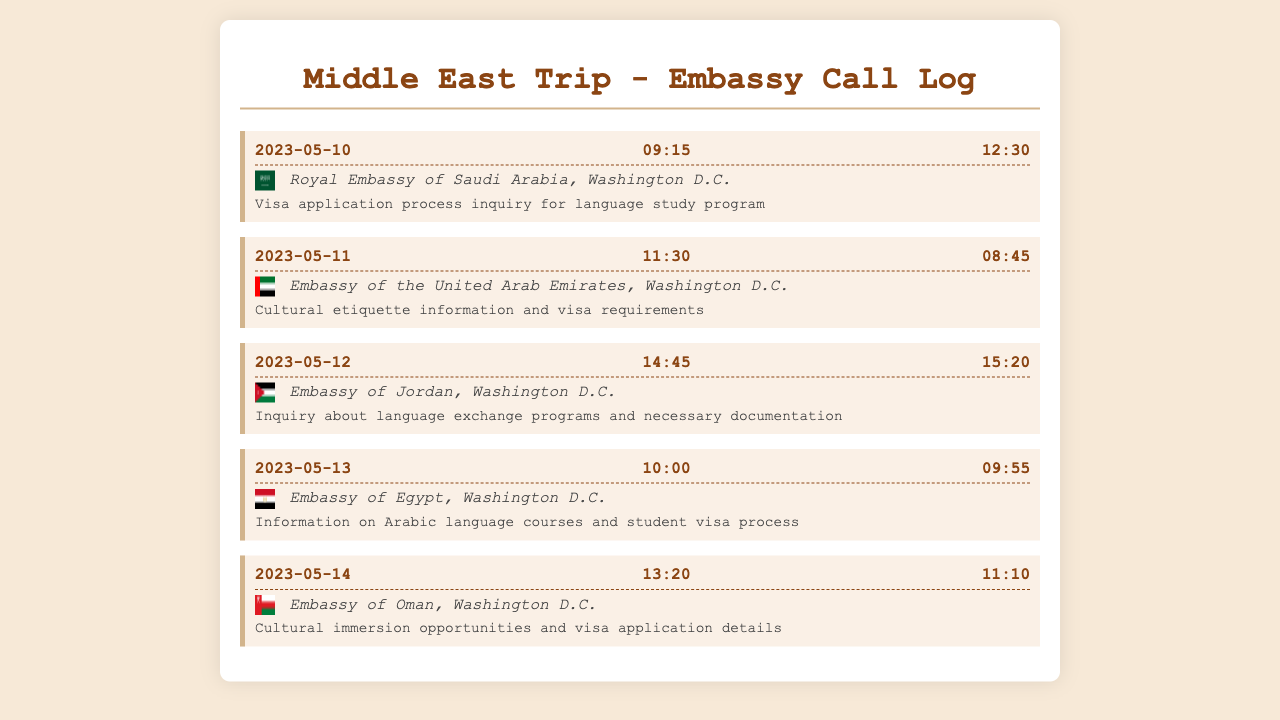what is the date of the first call? The first call in the log is on May 10, 2023.
Answer: 2023-05-10 how long was the call to the Embassy of the United Arab Emirates? The call to the Embassy of the United Arab Emirates lasted for 8 minutes and 45 seconds.
Answer: 08:45 which embassy was contacted for language exchange programs? The Embassy of Jordan was contacted for information related to language exchange programs.
Answer: Embassy of Jordan what kind of information was sought from the Embassy of Oman? The inquiry from the Embassy of Oman involved cultural immersion opportunities and visa application details.
Answer: Cultural immersion opportunities and visa application details how many total calls are recorded in the document? The document records a total of five calls made to various embassies and consulates.
Answer: 5 what purpose was the call to the Embassy of Egypt? The call to the Embassy of Egypt was about information on Arabic language courses and the student visa process.
Answer: Information on Arabic language courses and student visa process what time was the call made to the Royal Embassy of Saudi Arabia? The call to the Royal Embassy of Saudi Arabia was made at 9:15 AM.
Answer: 09:15 which embassy was contacted about cultural etiquette? The call about cultural etiquette was made to the Embassy of the United Arab Emirates.
Answer: Embassy of the United Arab Emirates 